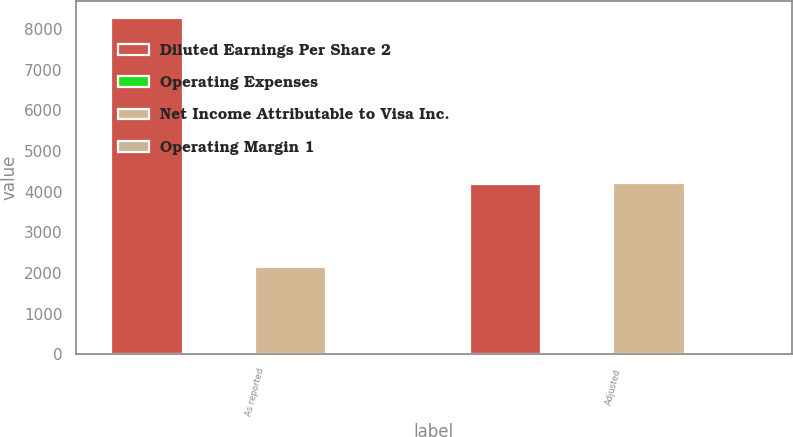<chart> <loc_0><loc_0><loc_500><loc_500><stacked_bar_chart><ecel><fcel>As reported<fcel>Adjusted<nl><fcel>Diluted Earnings Per Share 2<fcel>8282<fcel>4184<nl><fcel>Operating Expenses<fcel>21<fcel>60<nl><fcel>Net Income Attributable to Visa Inc.<fcel>2144<fcel>4203<nl><fcel>Operating Margin 1<fcel>3.16<fcel>6.2<nl></chart> 